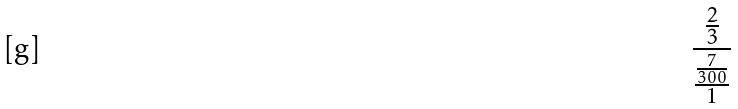Convert formula to latex. <formula><loc_0><loc_0><loc_500><loc_500>\frac { \frac { 2 } { 3 } } { \frac { \frac { 7 } { 3 0 0 } } { 1 } }</formula> 